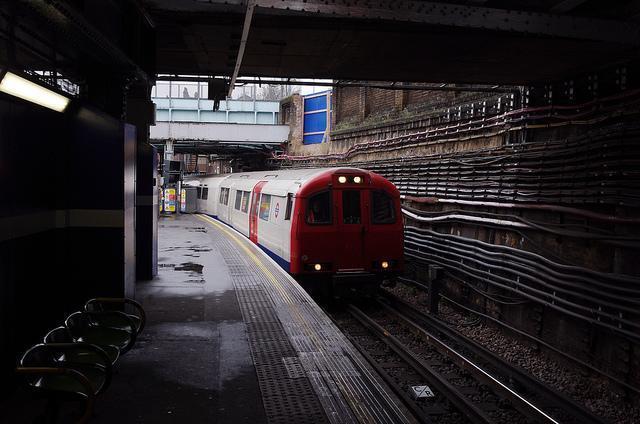How many trains are visible?
Give a very brief answer. 1. 